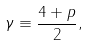<formula> <loc_0><loc_0><loc_500><loc_500>\gamma \equiv \frac { 4 + p } { 2 } ,</formula> 